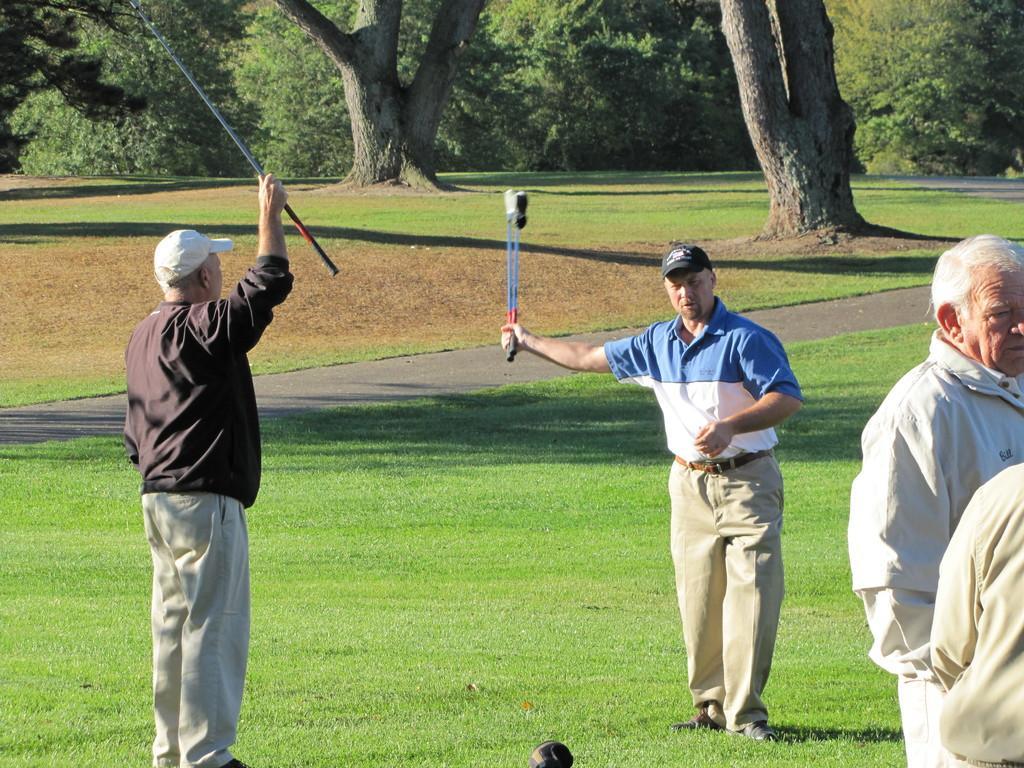Could you give a brief overview of what you see in this image? In this image we can see a group of people standing on the grass field. Some persons are holding sticks in their hands. In the background, we can see a group of trees. 